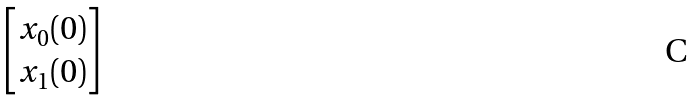<formula> <loc_0><loc_0><loc_500><loc_500>\begin{bmatrix} x _ { 0 } ( 0 ) \\ x _ { 1 } ( 0 ) \end{bmatrix}</formula> 